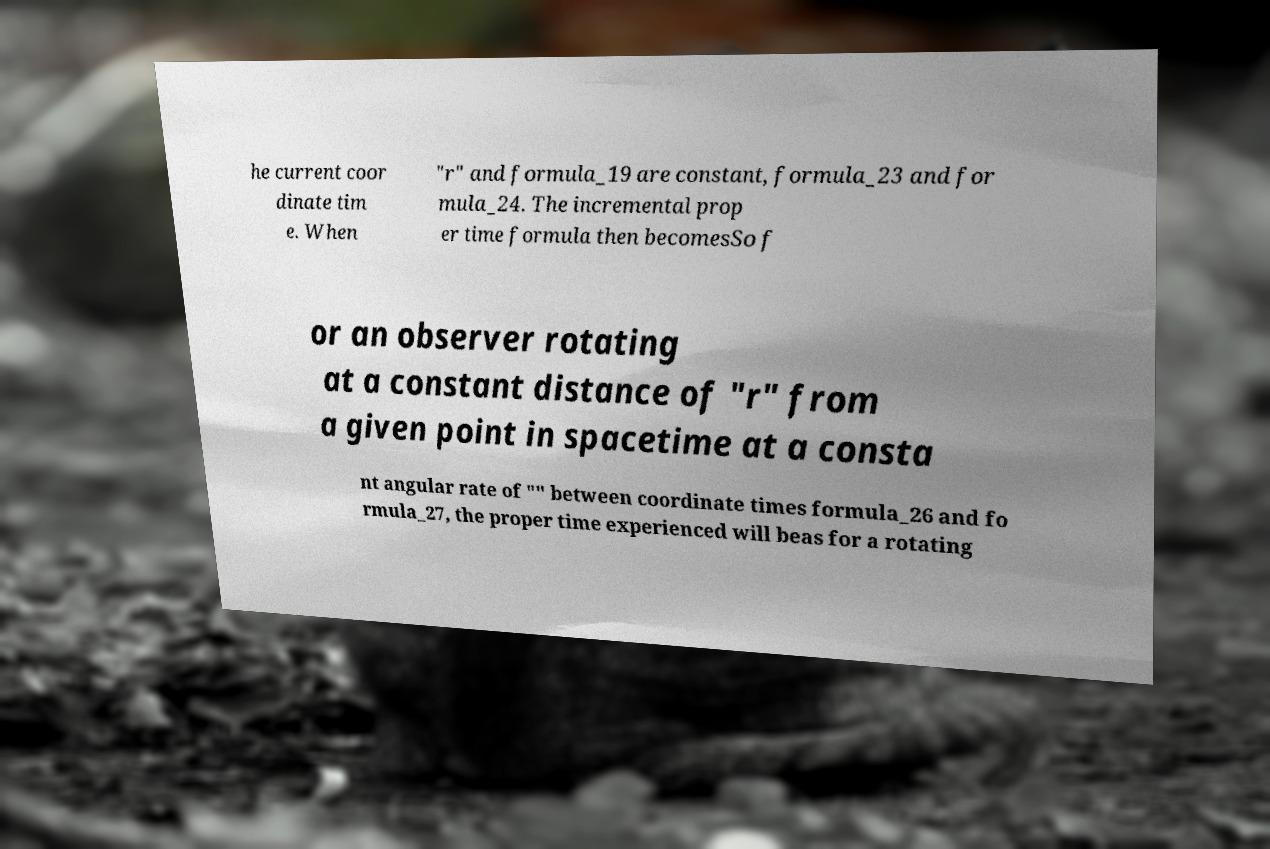For documentation purposes, I need the text within this image transcribed. Could you provide that? he current coor dinate tim e. When "r" and formula_19 are constant, formula_23 and for mula_24. The incremental prop er time formula then becomesSo f or an observer rotating at a constant distance of "r" from a given point in spacetime at a consta nt angular rate of "" between coordinate times formula_26 and fo rmula_27, the proper time experienced will beas for a rotating 